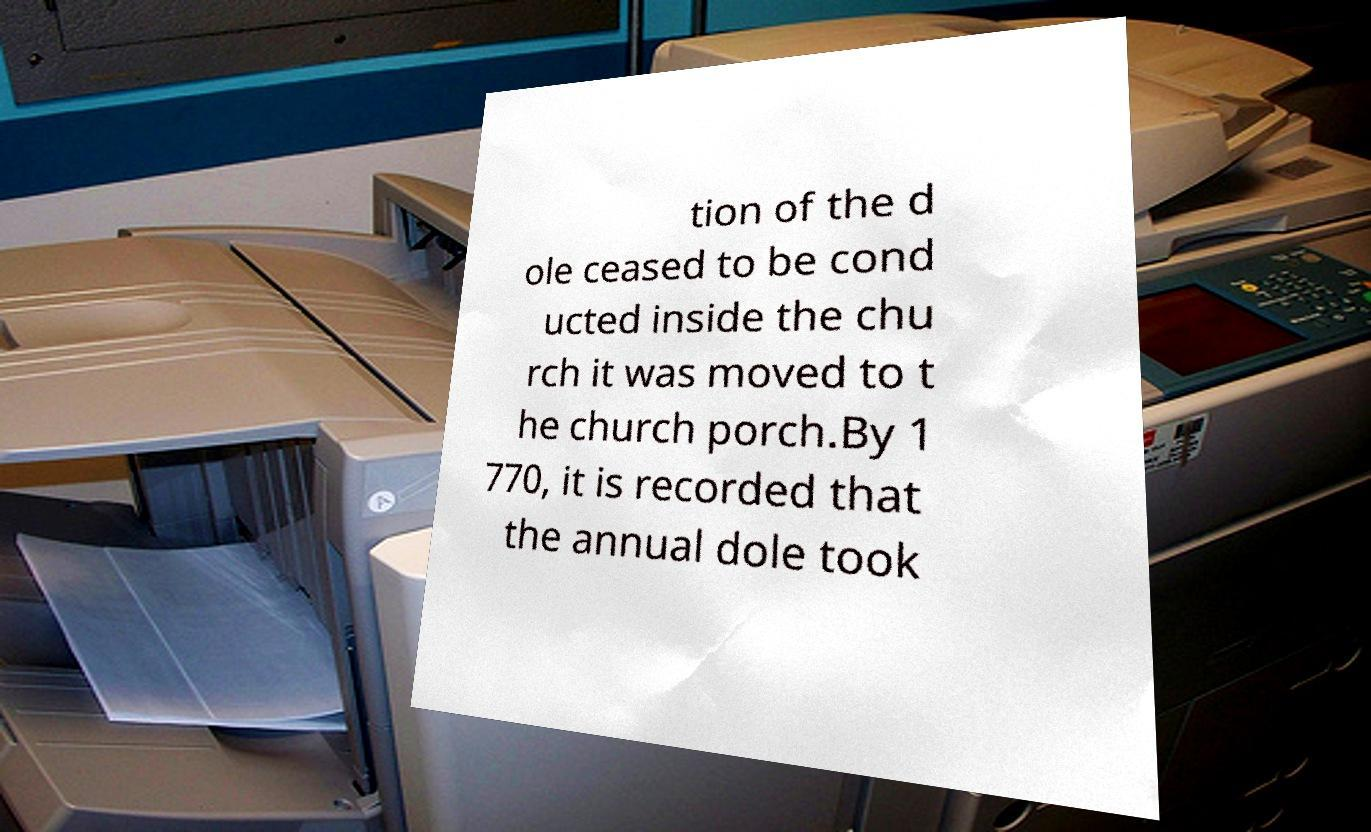Could you extract and type out the text from this image? tion of the d ole ceased to be cond ucted inside the chu rch it was moved to t he church porch.By 1 770, it is recorded that the annual dole took 